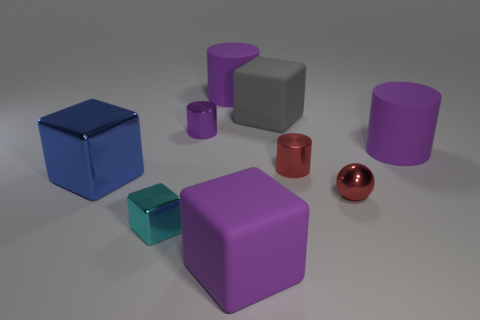How many purple cylinders must be subtracted to get 1 purple cylinders? 2 Add 1 big purple blocks. How many objects exist? 10 Subtract all red cylinders. How many cylinders are left? 3 Subtract all red cylinders. How many cylinders are left? 3 Subtract all spheres. How many objects are left? 8 Subtract all brown spheres. How many blue cubes are left? 1 Subtract all big purple rubber cylinders. Subtract all red cylinders. How many objects are left? 6 Add 4 big metal blocks. How many big metal blocks are left? 5 Add 9 big blue matte objects. How many big blue matte objects exist? 9 Subtract 1 red spheres. How many objects are left? 8 